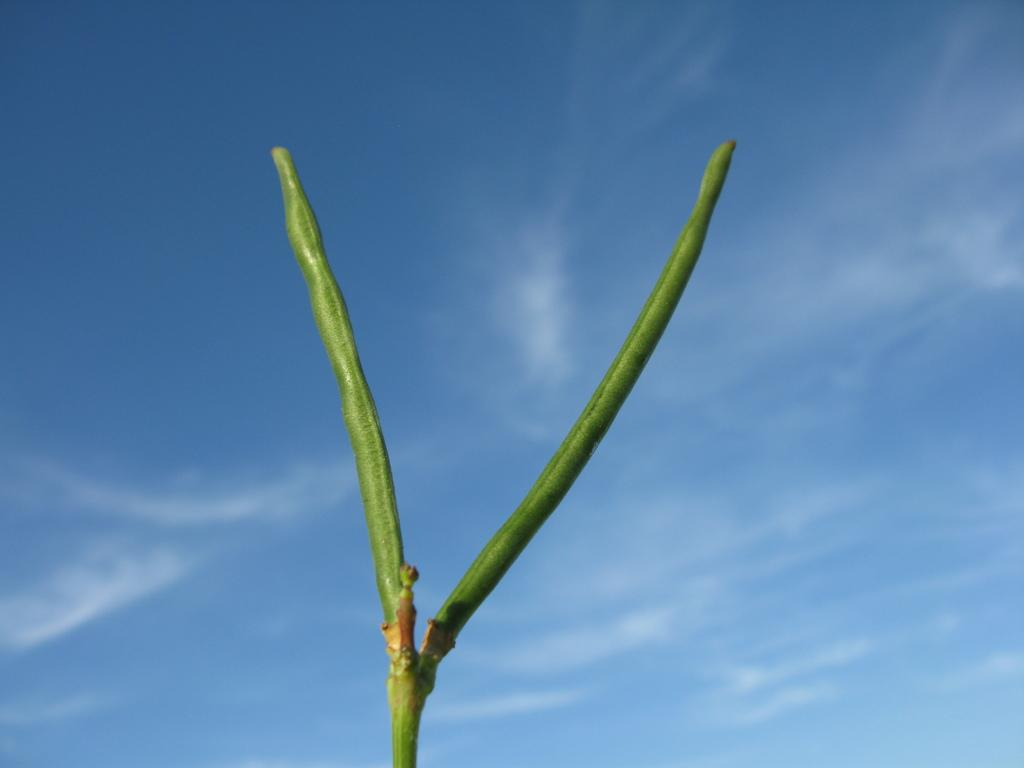What is the main subject of the image? The main subject of the image is a stem of a plant. What color is the background of the image? The background of the image is blue. Reasoning: Let'ing: Let's think step by step in order to produce the conversation. We start by identifying the main subject of the image, which is the stem of a plant. Then, we describe the background color, which is blue. We avoid asking questions that cannot be answered definitively with the information given. Absurd Question/Answer: What type of metal can be seen on the top of the branch in the image? There is no branch or metal present in the image; it only features a stem of a plant and a blue background. What type of metal can be seen on the top of the branch in the image? There is no branch or metal present in the image; it only features a stem of a plant and a blue background. 